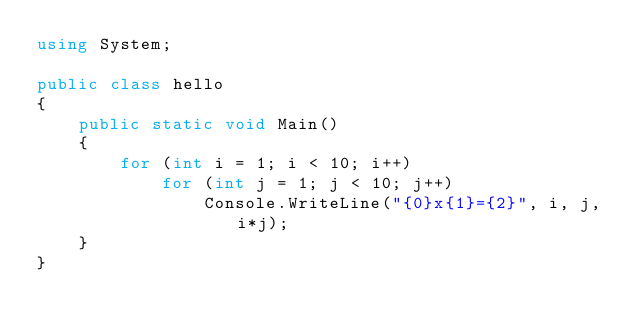<code> <loc_0><loc_0><loc_500><loc_500><_C#_>using System;

public class hello
{
    public static void Main()
    {
        for (int i = 1; i < 10; i++)
            for (int j = 1; j < 10; j++)
                Console.WriteLine("{0}x{1}={2}", i, j,i*j);
    }
}</code> 